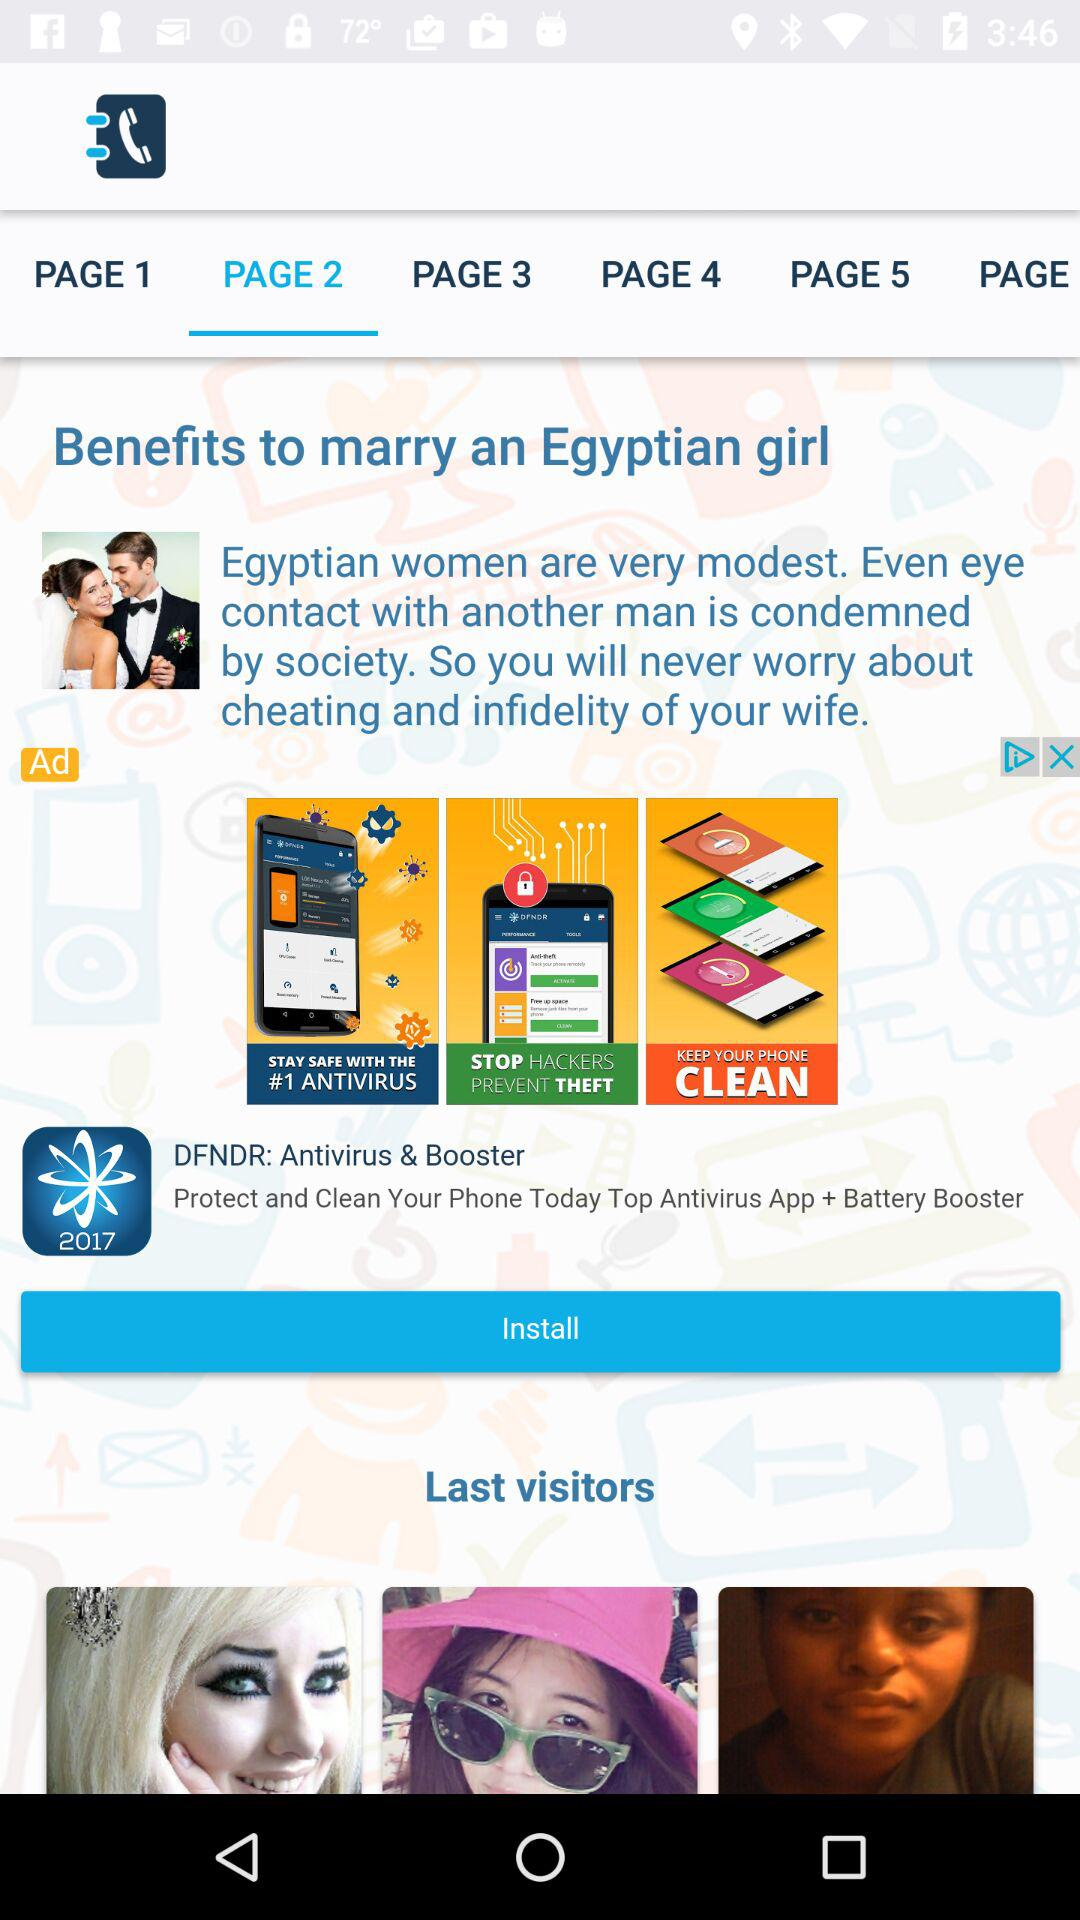Which page is selected? The selected page is "PAGE 2". 